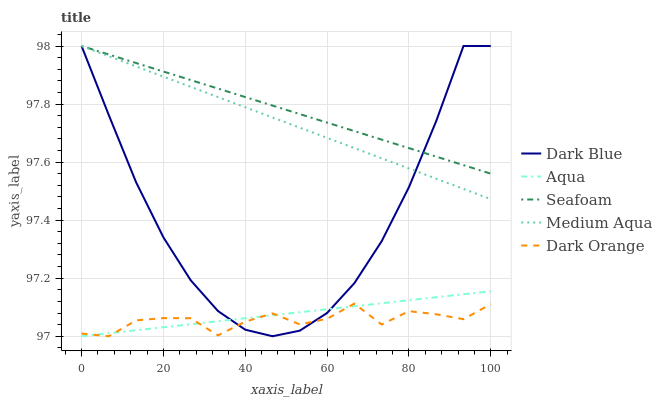Does Dark Blue have the minimum area under the curve?
Answer yes or no. No. Does Dark Blue have the maximum area under the curve?
Answer yes or no. No. Is Dark Blue the smoothest?
Answer yes or no. No. Is Dark Blue the roughest?
Answer yes or no. No. Does Dark Blue have the lowest value?
Answer yes or no. No. Does Aqua have the highest value?
Answer yes or no. No. Is Dark Orange less than Medium Aqua?
Answer yes or no. Yes. Is Seafoam greater than Aqua?
Answer yes or no. Yes. Does Dark Orange intersect Medium Aqua?
Answer yes or no. No. 